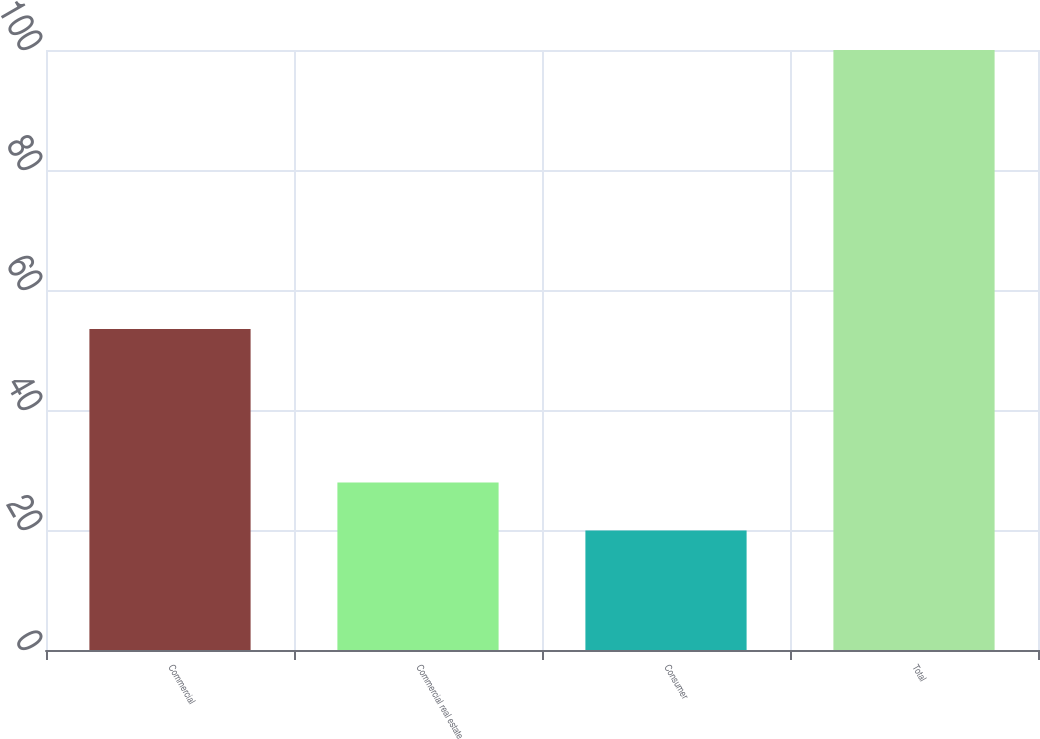Convert chart to OTSL. <chart><loc_0><loc_0><loc_500><loc_500><bar_chart><fcel>Commercial<fcel>Commercial real estate<fcel>Consumer<fcel>Total<nl><fcel>53.5<fcel>27.91<fcel>19.9<fcel>100<nl></chart> 